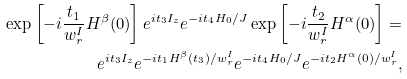<formula> <loc_0><loc_0><loc_500><loc_500>\exp \left [ - i \frac { t _ { 1 } } { w _ { r } ^ { I } } H ^ { \beta } ( 0 ) \right ] e ^ { i t _ { 3 } I _ { z } } e ^ { - i t _ { 4 } H _ { 0 } / J } \exp \left [ - i \frac { t _ { 2 } } { w _ { r } ^ { I } } H ^ { \alpha } ( 0 ) \right ] = \\ e ^ { i t _ { 3 } I _ { z } } e ^ { - i t _ { 1 } H ^ { \beta } ( t _ { 3 } ) / w _ { r } ^ { I } } e ^ { - i t _ { 4 } H _ { 0 } / J } e ^ { - i t _ { 2 } H ^ { \alpha } ( 0 ) / w _ { r } ^ { I } } ,</formula> 